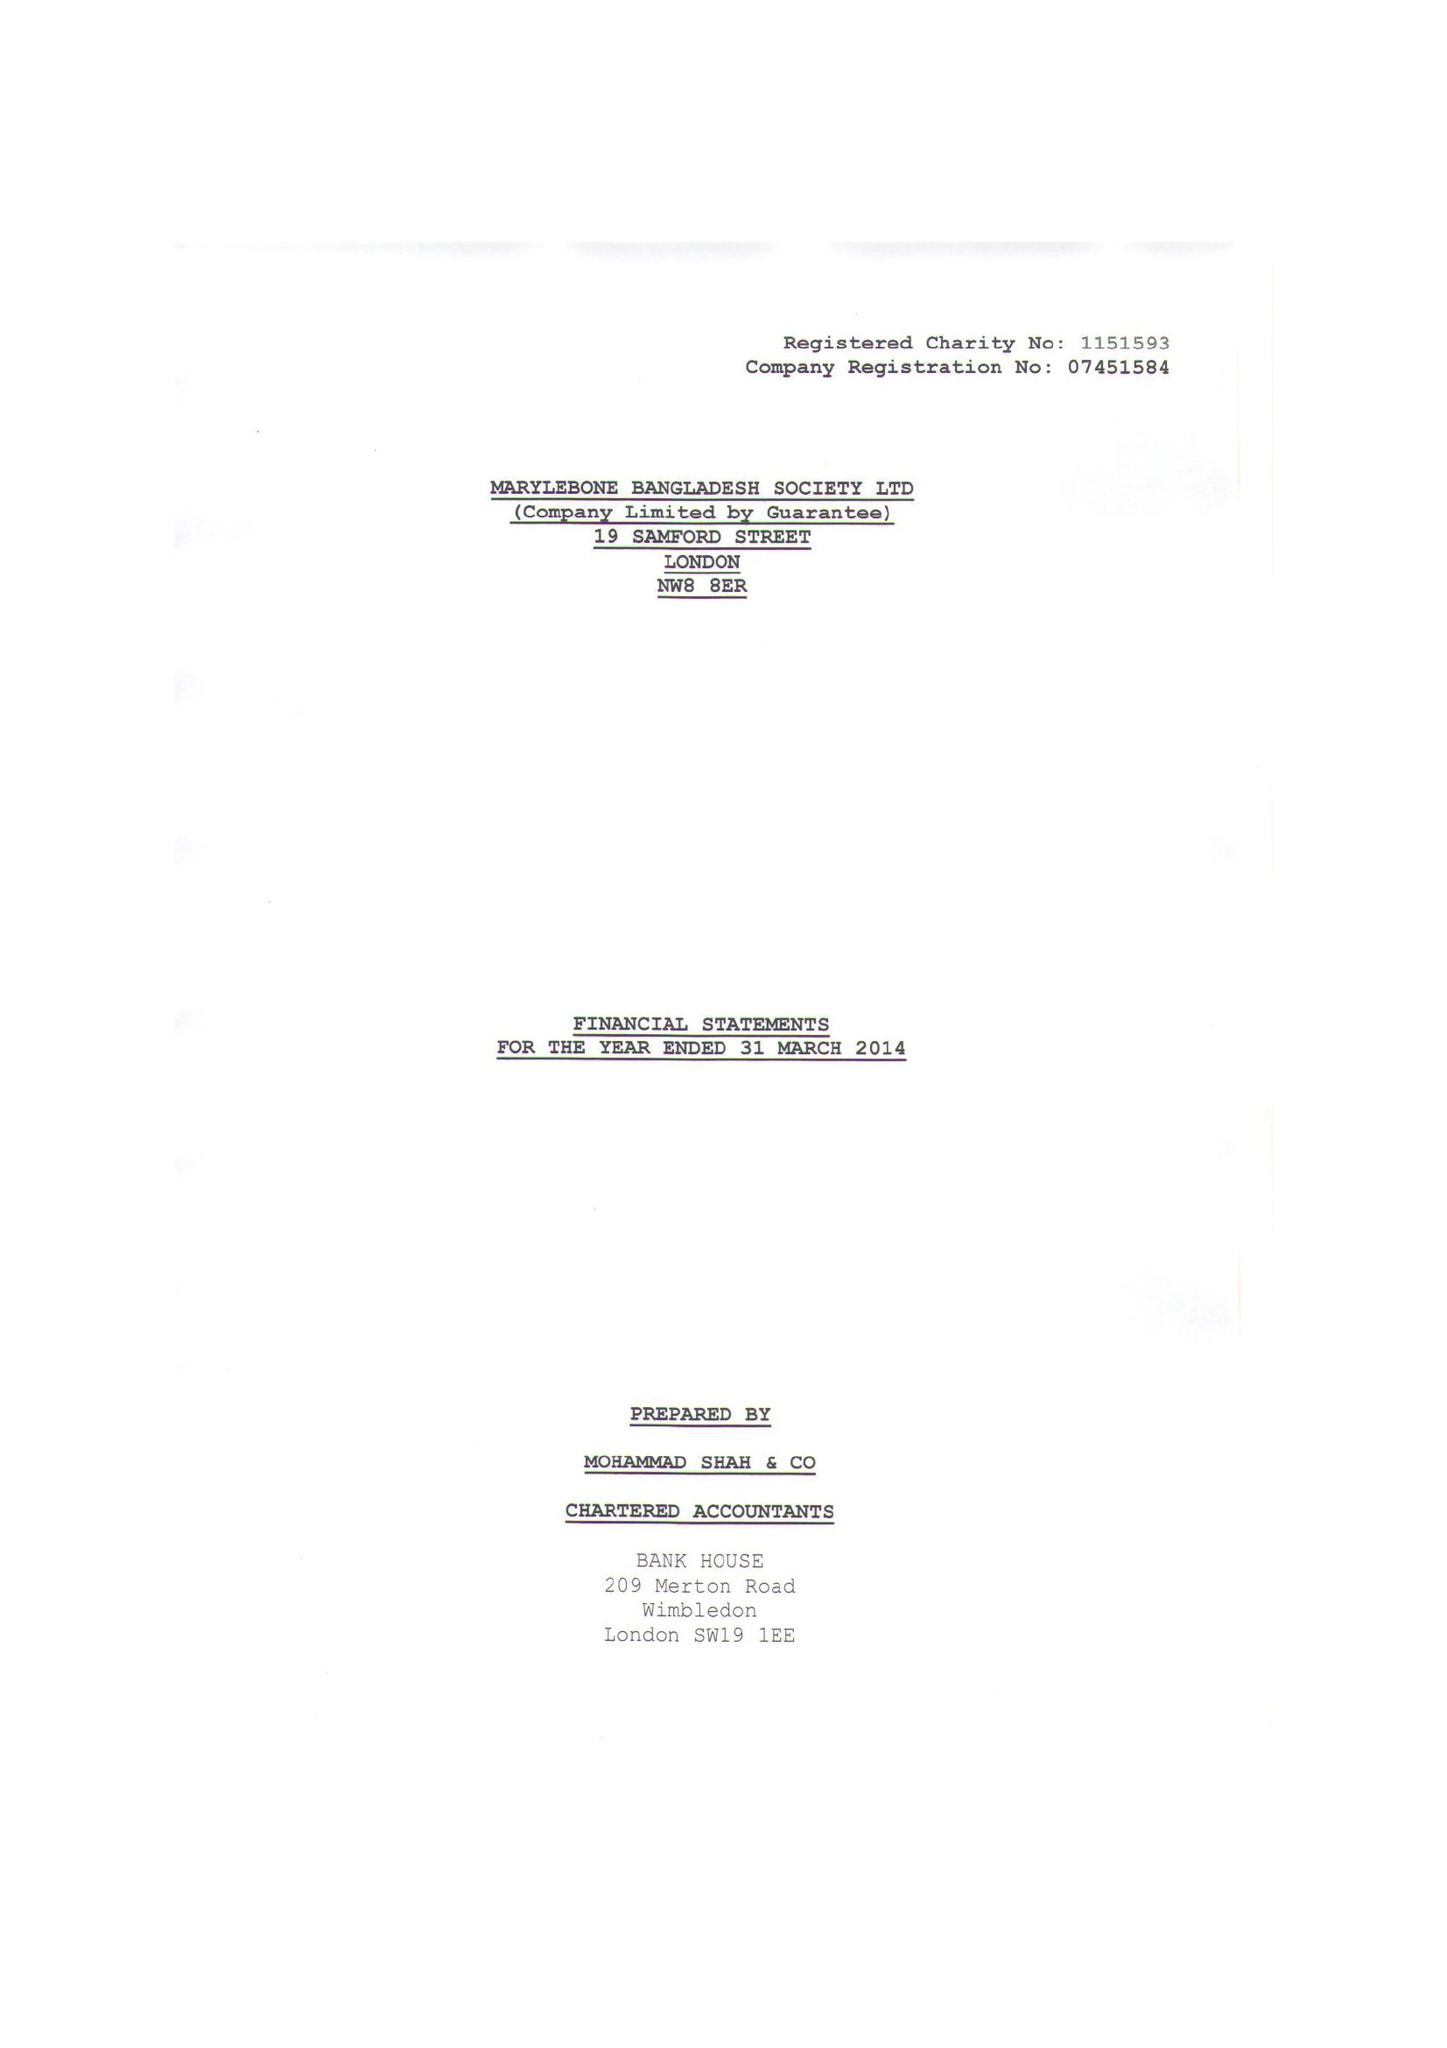What is the value for the charity_number?
Answer the question using a single word or phrase. 1151593 